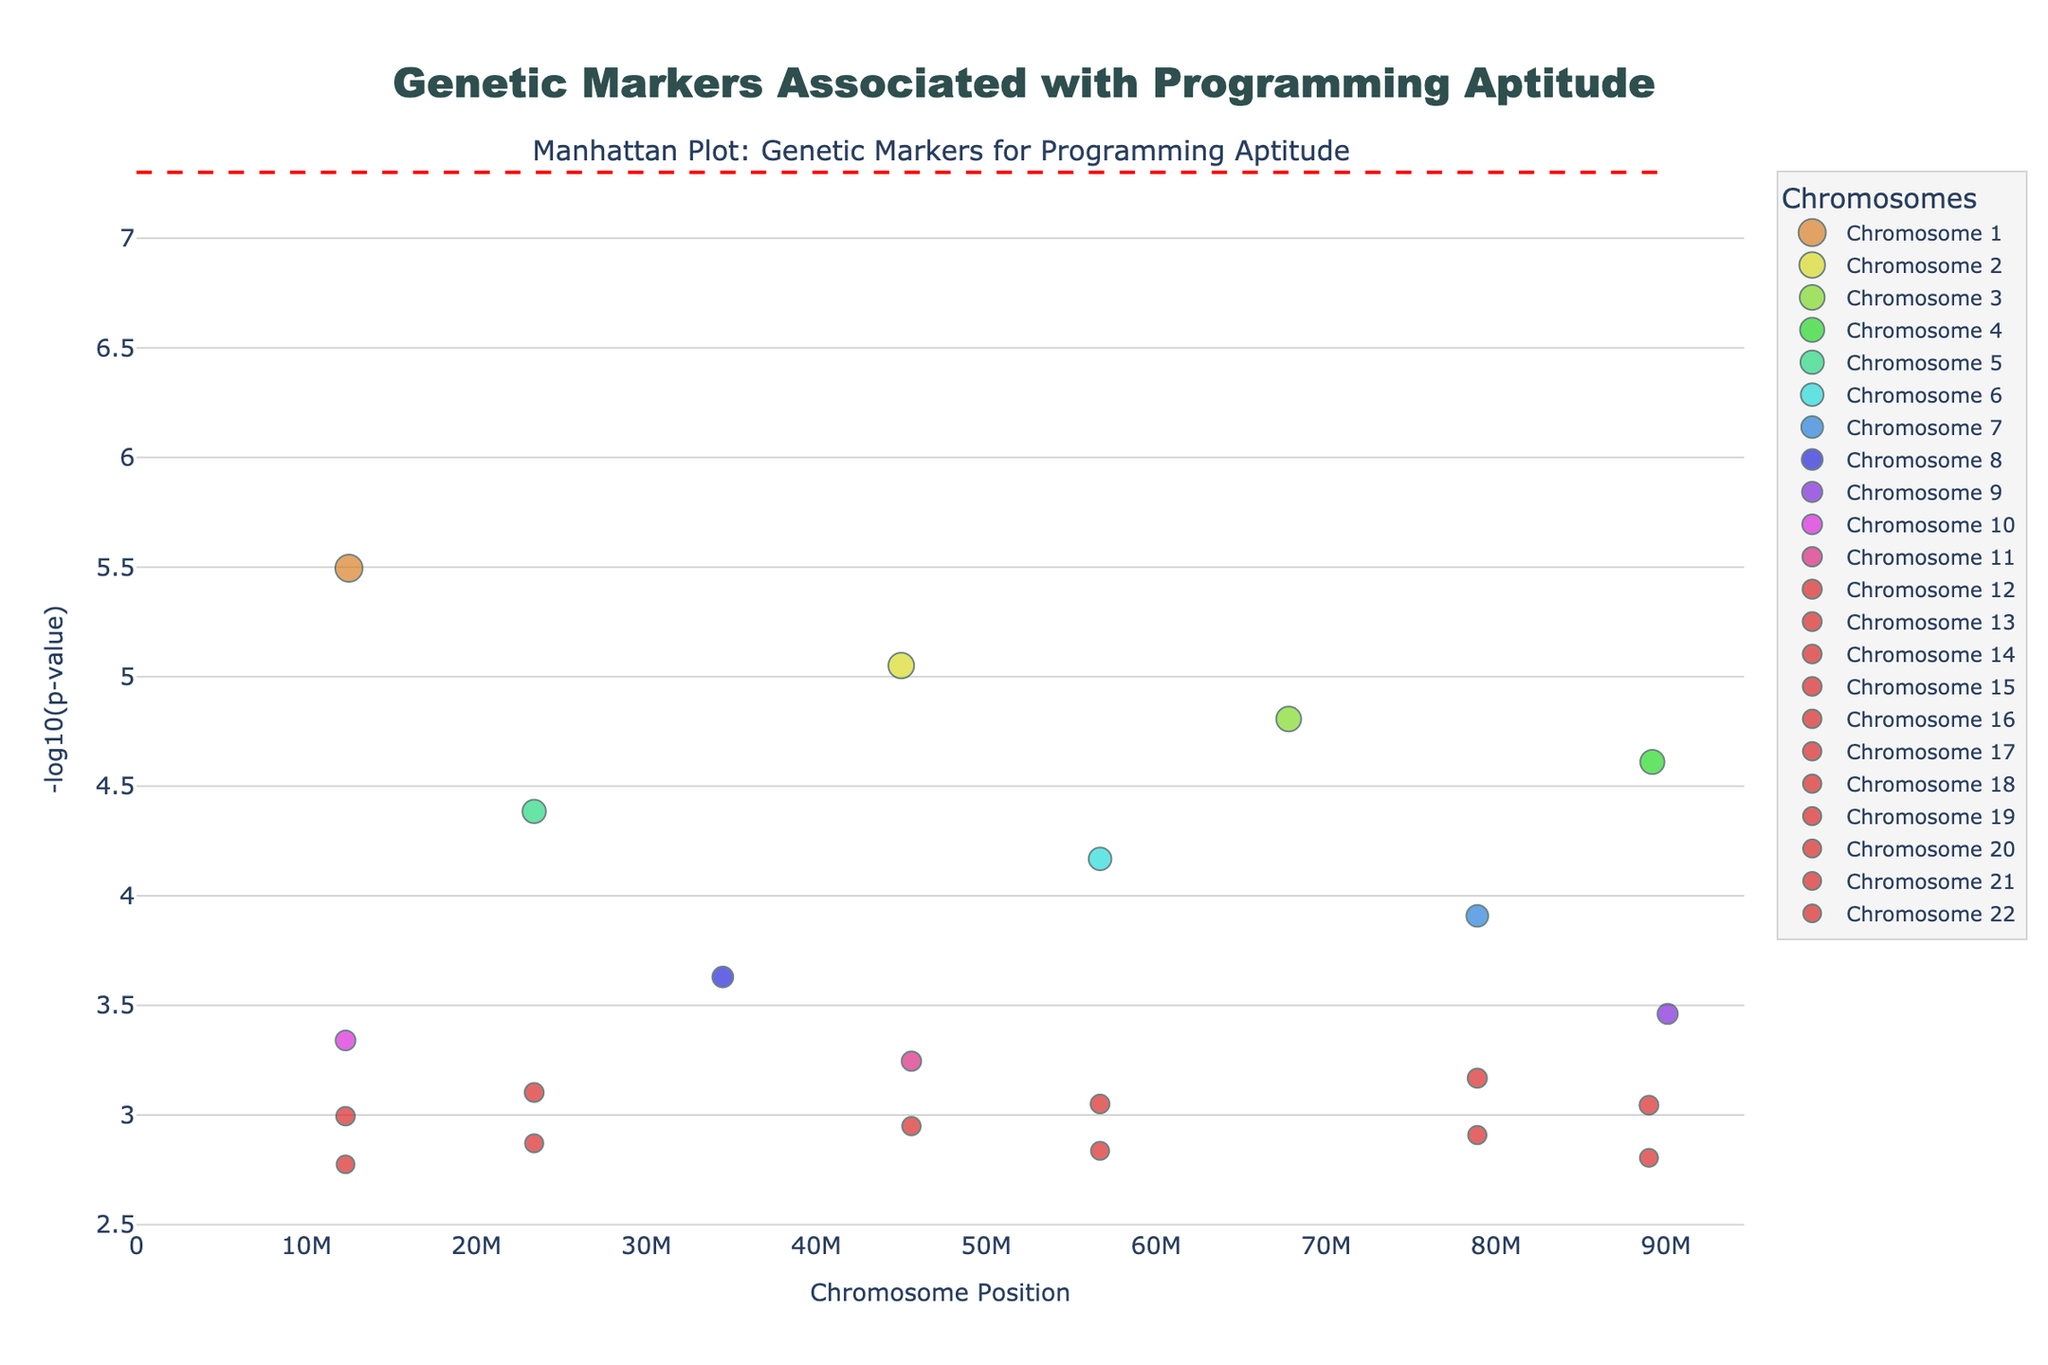What's the title of the plot? Look at the title centered at the top of the plot.
Answer: Genetic Markers Associated with Programming Aptitude What's represented on the X-axis? Observe the text next to the X-axis, indicating what it represents.
Answer: Chromosome Position What does the Y-axis represent? Check the label of the Y-axis which describes the data it holds.
Answer: -log10(p-value) How many chromosomes are displayed in the plot? Count the distinct chromosome labels in the legend on the right side of the plot.
Answer: 22 Which SNP has the smallest P-value? Identify the highest data point on the Y-axis as it represents the smallest P-value.
Answer: rs7412 What is the significance threshold set in the plot? Find the location of the horizontal red dashed line and read its Y-value.
Answer: -log10(5e-8) Which chromosome has the highest data point related to position? Observe the position on the X-axis for the highest data points relative to chromosomes. Chromosome with the maximum X-axis value has the highest position.
Answer: Chromosome 21 How many SNPs are above the significance threshold? Count all data points (dots) above the horizontal red dashed significance line.
Answer: 2 What's the average -log10(p-value) for SNPs on Chromosome 1? Calculate the sum of the -log10(p-value) for all SNPs on Chromosome 1, then divide by the number of such SNPs. Given Chromosome 1 has only one SNP: -log10(0.0000032) ≈ 5.49
Answer: 5.49 Which chromosome has the widest spread in chromosome positions? Measure the range (difference between max and min) of X-axis values for SNP positions within each chromosome and compare.
Answer: Chromosome 21 